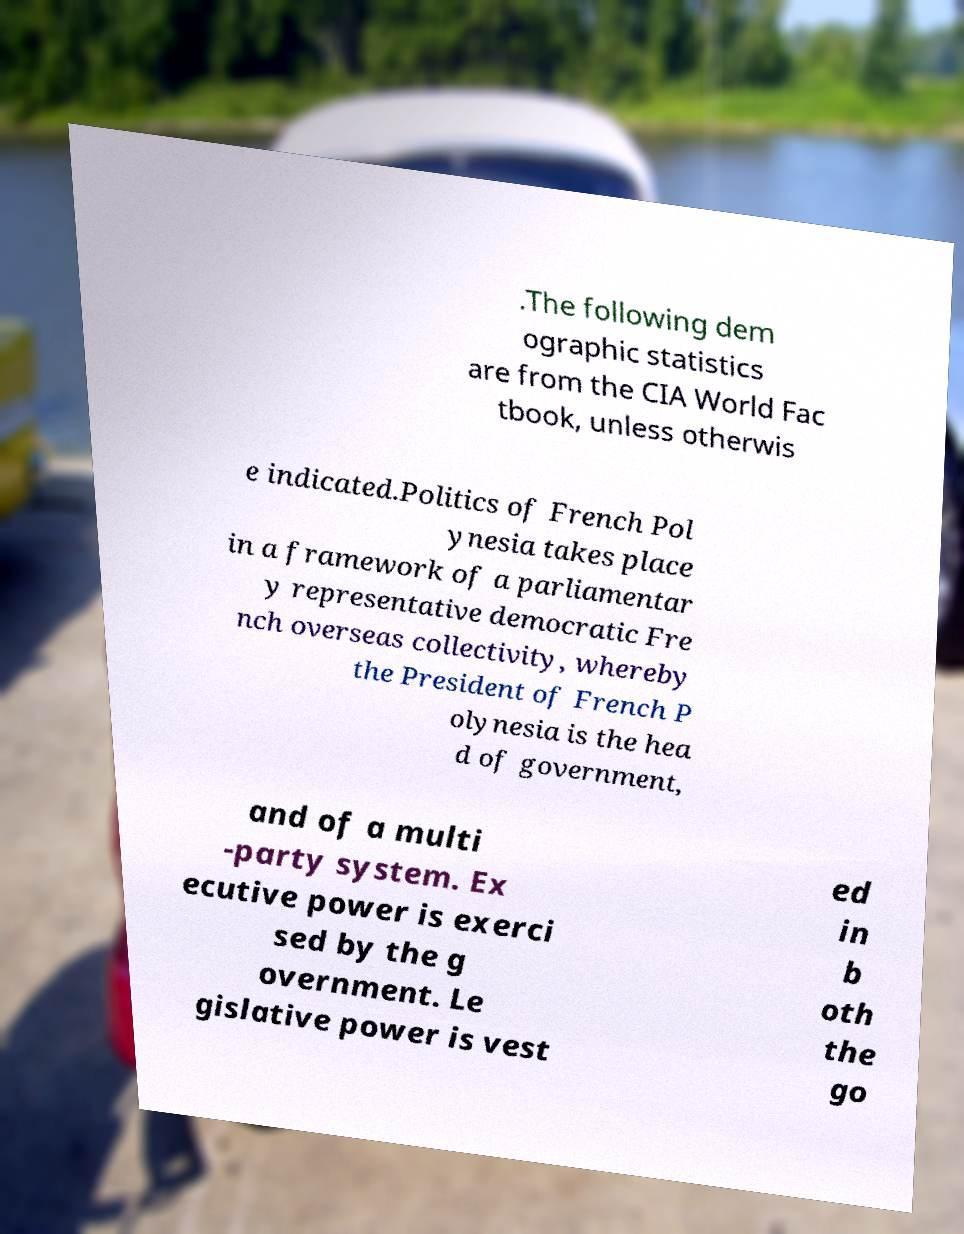Please read and relay the text visible in this image. What does it say? .The following dem ographic statistics are from the CIA World Fac tbook, unless otherwis e indicated.Politics of French Pol ynesia takes place in a framework of a parliamentar y representative democratic Fre nch overseas collectivity, whereby the President of French P olynesia is the hea d of government, and of a multi -party system. Ex ecutive power is exerci sed by the g overnment. Le gislative power is vest ed in b oth the go 